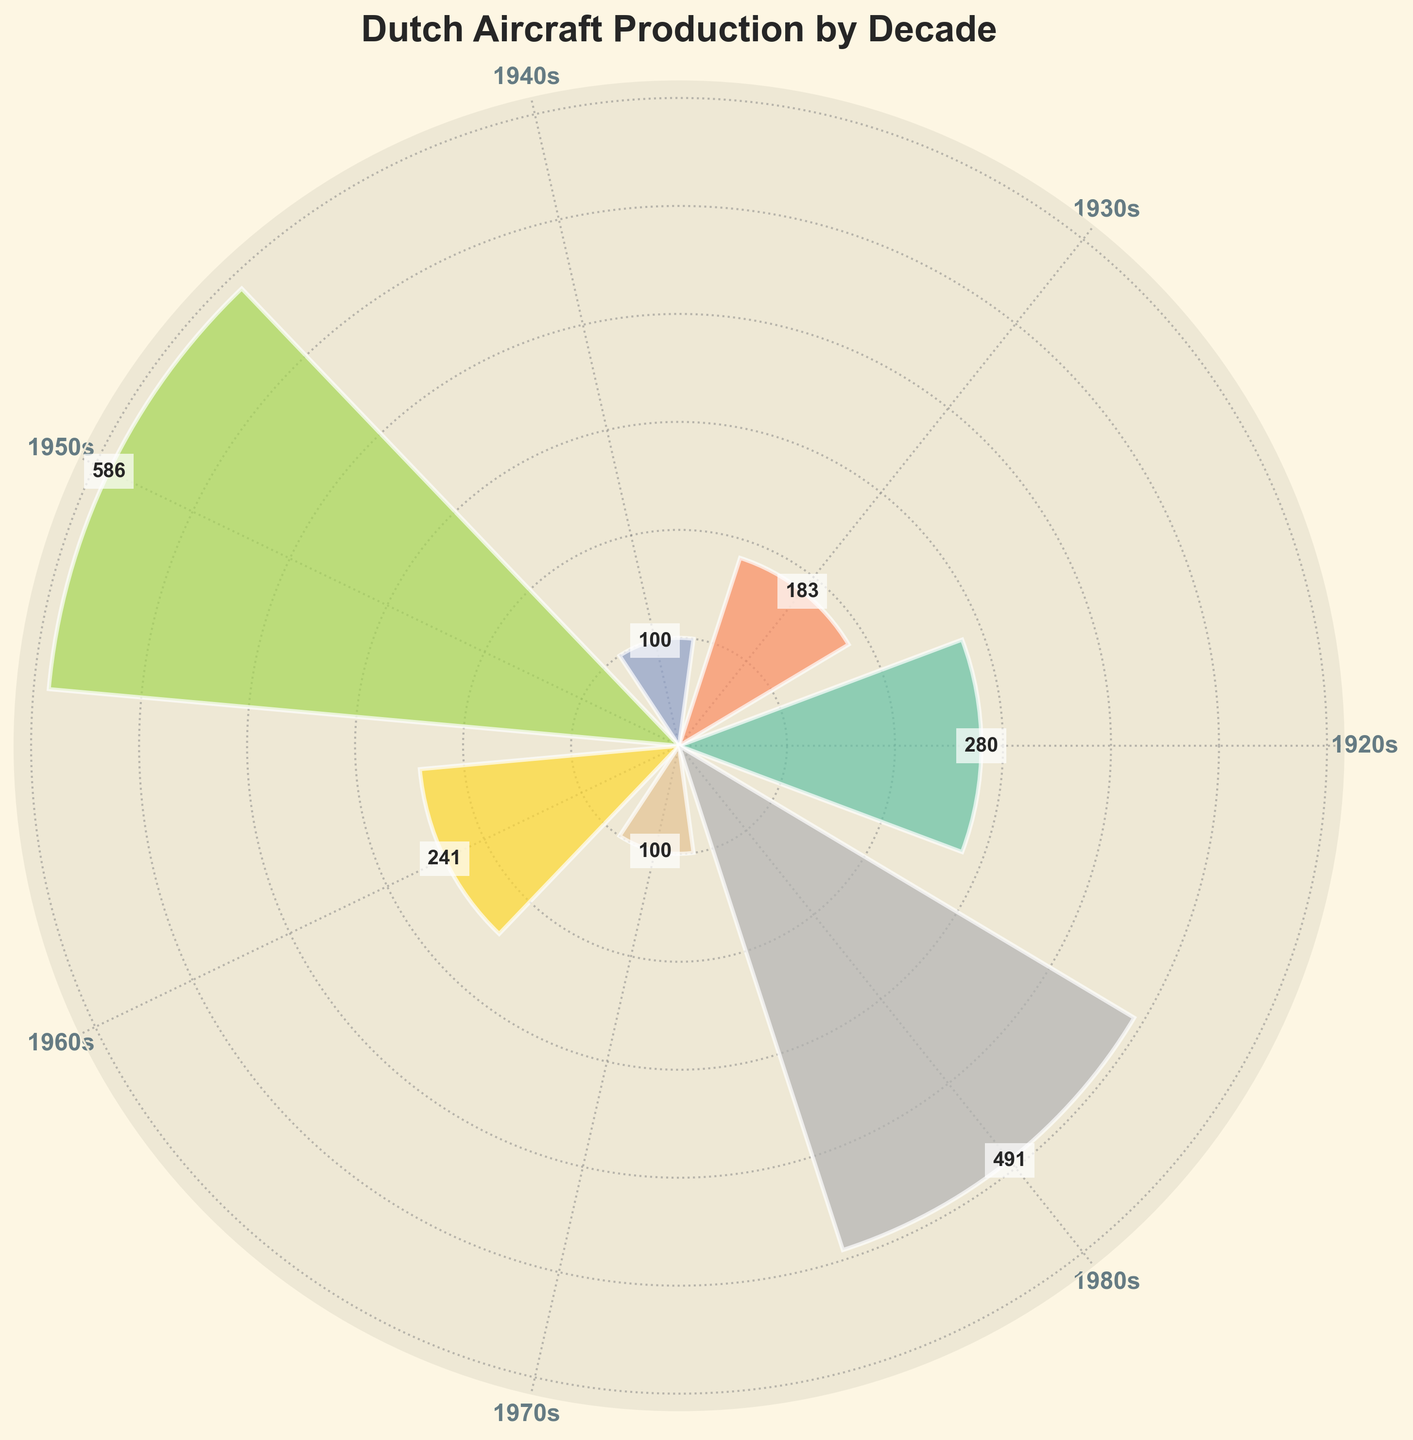What's the title of the chart? The title is usually found at the top of the chart. Here, the title is "Dutch Aircraft Production by Decade".
Answer: Dutch Aircraft Production by Decade How many data points (decades) are represented in the chart? You can count the distinct segments or labels on the chart. There are 6 segments, each representing a decade.
Answer: 6 Which decade had the highest aircraft production? By comparing the length of the bars, the decade with the longest bar represents the highest production. The 1950s have the longest bar.
Answer: 1950s What is the total number of aircraft produced in the 1920s? The 1920s segment shows two numbers on the bar (200 for the Fokker C.I and 80 for the Fokker F.VII). Summing these gives 280.
Answer: 280 Compare the 1950s and the 1960s in terms of aircraft production. Which had more? Measure the bars for both decades. The 1950s bar is longer, indicating more aircraft production. The 1950s had 586, and the 1960s had 241.
Answer: 1950s Which decade saw an increase in aircraft production compared to the previous decade? Compare sequential decades by the length of the bars. The 1980s (with 491) saw an increase compared to the 1970s (with 100).
Answer: 1980s What is the difference in aircraft production between the 1930s and 1940s? Locate the bars for the 1930s and 1940s and compare their lengths. The 1930s had 183, and the 1940s had 100. The difference is 183 - 100.
Answer: 83 How many groups produced aircraft in the 1980s? For the 1980s segment, there are two numbers on the bar (213 for the Fokker 50 and 278 for the Fokker 100).
Answer: 2 What was the average number of aircraft produced per decade? Sum the values of all the decades and divide by the number of decades. (280+183+100+586+241+491) / 6.
Answer: 313.5 